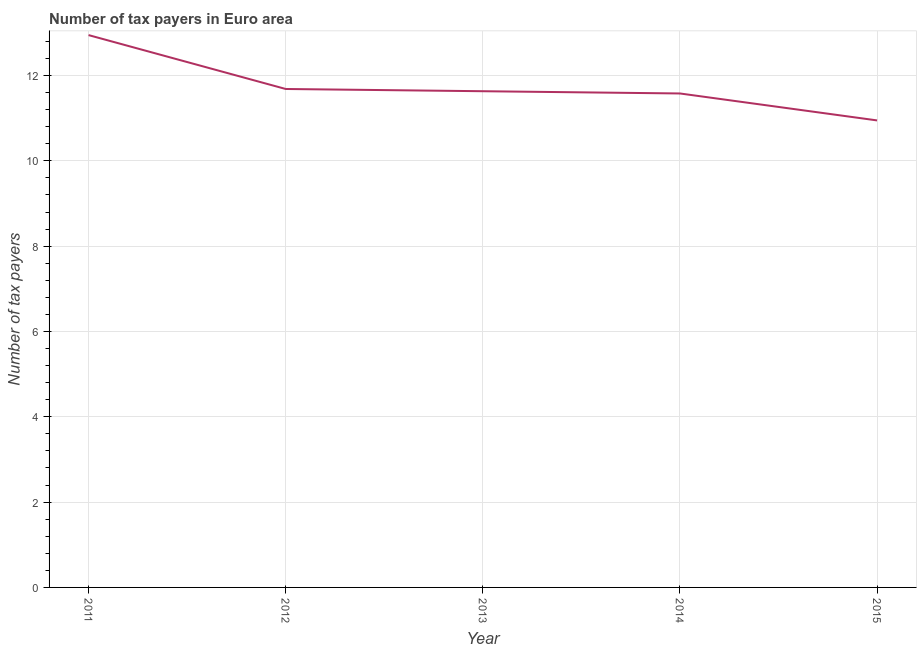What is the number of tax payers in 2014?
Make the answer very short. 11.58. Across all years, what is the maximum number of tax payers?
Your response must be concise. 12.95. Across all years, what is the minimum number of tax payers?
Provide a succinct answer. 10.95. In which year was the number of tax payers minimum?
Provide a short and direct response. 2015. What is the sum of the number of tax payers?
Provide a short and direct response. 58.79. What is the difference between the number of tax payers in 2012 and 2015?
Give a very brief answer. 0.74. What is the average number of tax payers per year?
Keep it short and to the point. 11.76. What is the median number of tax payers?
Keep it short and to the point. 11.63. What is the ratio of the number of tax payers in 2013 to that in 2014?
Provide a short and direct response. 1. Is the difference between the number of tax payers in 2011 and 2014 greater than the difference between any two years?
Provide a succinct answer. No. What is the difference between the highest and the second highest number of tax payers?
Ensure brevity in your answer.  1.26. How many lines are there?
Your answer should be very brief. 1. How many years are there in the graph?
Make the answer very short. 5. Are the values on the major ticks of Y-axis written in scientific E-notation?
Keep it short and to the point. No. What is the title of the graph?
Offer a very short reply. Number of tax payers in Euro area. What is the label or title of the X-axis?
Offer a terse response. Year. What is the label or title of the Y-axis?
Make the answer very short. Number of tax payers. What is the Number of tax payers in 2011?
Keep it short and to the point. 12.95. What is the Number of tax payers in 2012?
Offer a very short reply. 11.68. What is the Number of tax payers in 2013?
Make the answer very short. 11.63. What is the Number of tax payers in 2014?
Your response must be concise. 11.58. What is the Number of tax payers of 2015?
Your answer should be very brief. 10.95. What is the difference between the Number of tax payers in 2011 and 2012?
Your answer should be compact. 1.26. What is the difference between the Number of tax payers in 2011 and 2013?
Give a very brief answer. 1.32. What is the difference between the Number of tax payers in 2011 and 2014?
Make the answer very short. 1.37. What is the difference between the Number of tax payers in 2011 and 2015?
Your answer should be very brief. 2. What is the difference between the Number of tax payers in 2012 and 2013?
Offer a terse response. 0.05. What is the difference between the Number of tax payers in 2012 and 2014?
Offer a terse response. 0.11. What is the difference between the Number of tax payers in 2012 and 2015?
Offer a very short reply. 0.74. What is the difference between the Number of tax payers in 2013 and 2014?
Give a very brief answer. 0.05. What is the difference between the Number of tax payers in 2013 and 2015?
Your answer should be compact. 0.68. What is the difference between the Number of tax payers in 2014 and 2015?
Your answer should be very brief. 0.63. What is the ratio of the Number of tax payers in 2011 to that in 2012?
Give a very brief answer. 1.11. What is the ratio of the Number of tax payers in 2011 to that in 2013?
Offer a very short reply. 1.11. What is the ratio of the Number of tax payers in 2011 to that in 2014?
Provide a succinct answer. 1.12. What is the ratio of the Number of tax payers in 2011 to that in 2015?
Provide a succinct answer. 1.18. What is the ratio of the Number of tax payers in 2012 to that in 2014?
Keep it short and to the point. 1.01. What is the ratio of the Number of tax payers in 2012 to that in 2015?
Offer a very short reply. 1.07. What is the ratio of the Number of tax payers in 2013 to that in 2014?
Give a very brief answer. 1. What is the ratio of the Number of tax payers in 2013 to that in 2015?
Ensure brevity in your answer.  1.06. What is the ratio of the Number of tax payers in 2014 to that in 2015?
Provide a succinct answer. 1.06. 